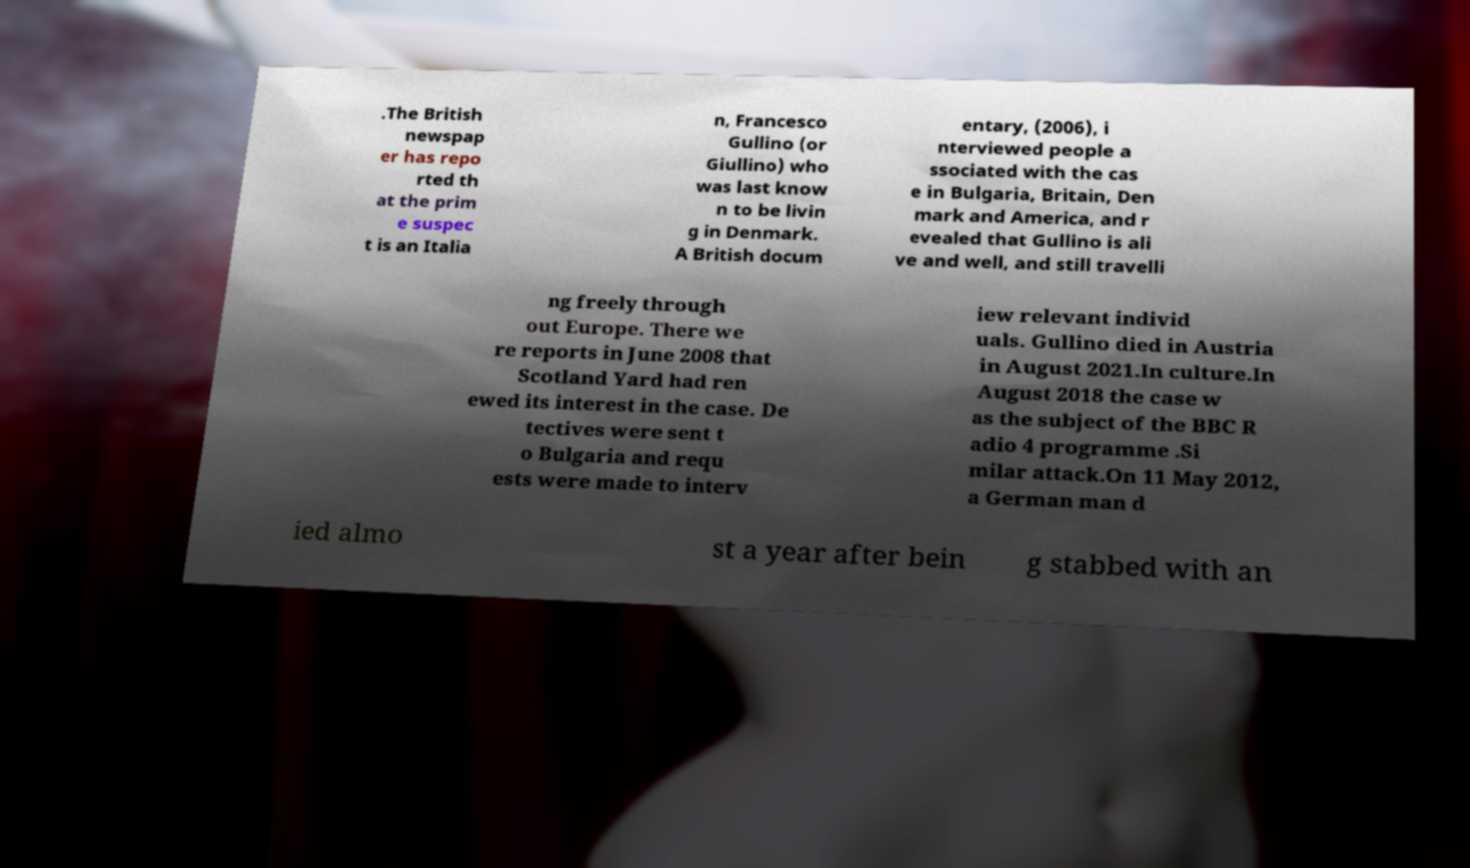There's text embedded in this image that I need extracted. Can you transcribe it verbatim? .The British newspap er has repo rted th at the prim e suspec t is an Italia n, Francesco Gullino (or Giullino) who was last know n to be livin g in Denmark. A British docum entary, (2006), i nterviewed people a ssociated with the cas e in Bulgaria, Britain, Den mark and America, and r evealed that Gullino is ali ve and well, and still travelli ng freely through out Europe. There we re reports in June 2008 that Scotland Yard had ren ewed its interest in the case. De tectives were sent t o Bulgaria and requ ests were made to interv iew relevant individ uals. Gullino died in Austria in August 2021.In culture.In August 2018 the case w as the subject of the BBC R adio 4 programme .Si milar attack.On 11 May 2012, a German man d ied almo st a year after bein g stabbed with an 